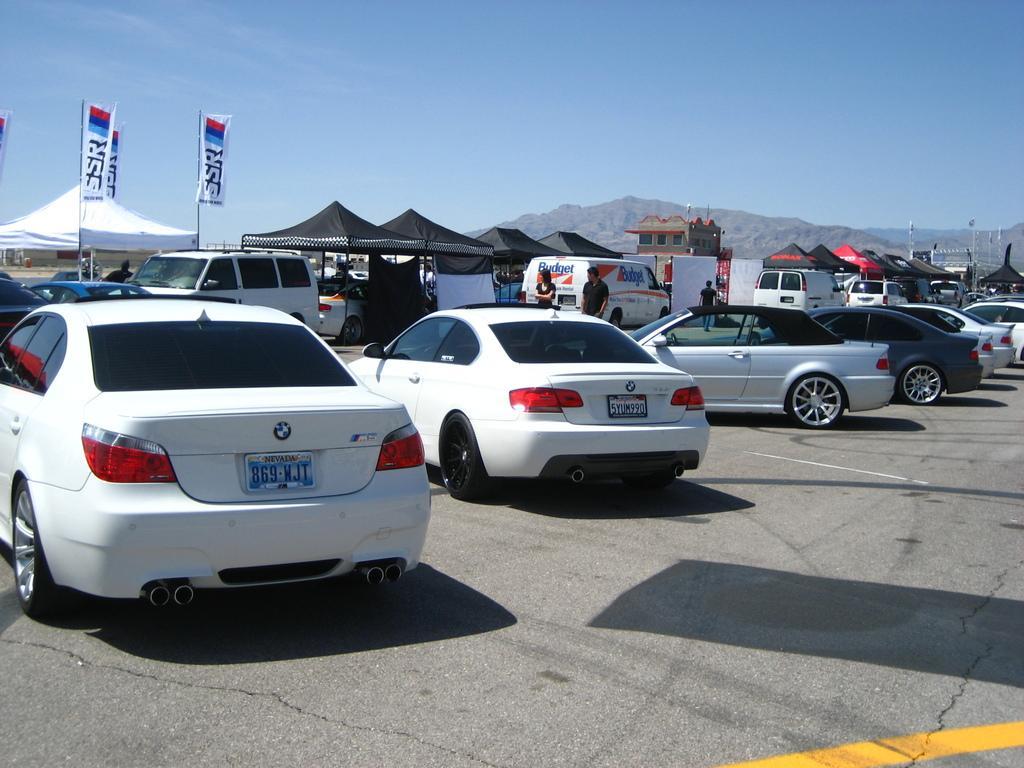In one or two sentences, can you explain what this image depicts? In the foreground of this image, there are cars on the road. In the background, there are cars, vans, tents, flags, poles, few boards, a building, mountains, sky and the cloud. 